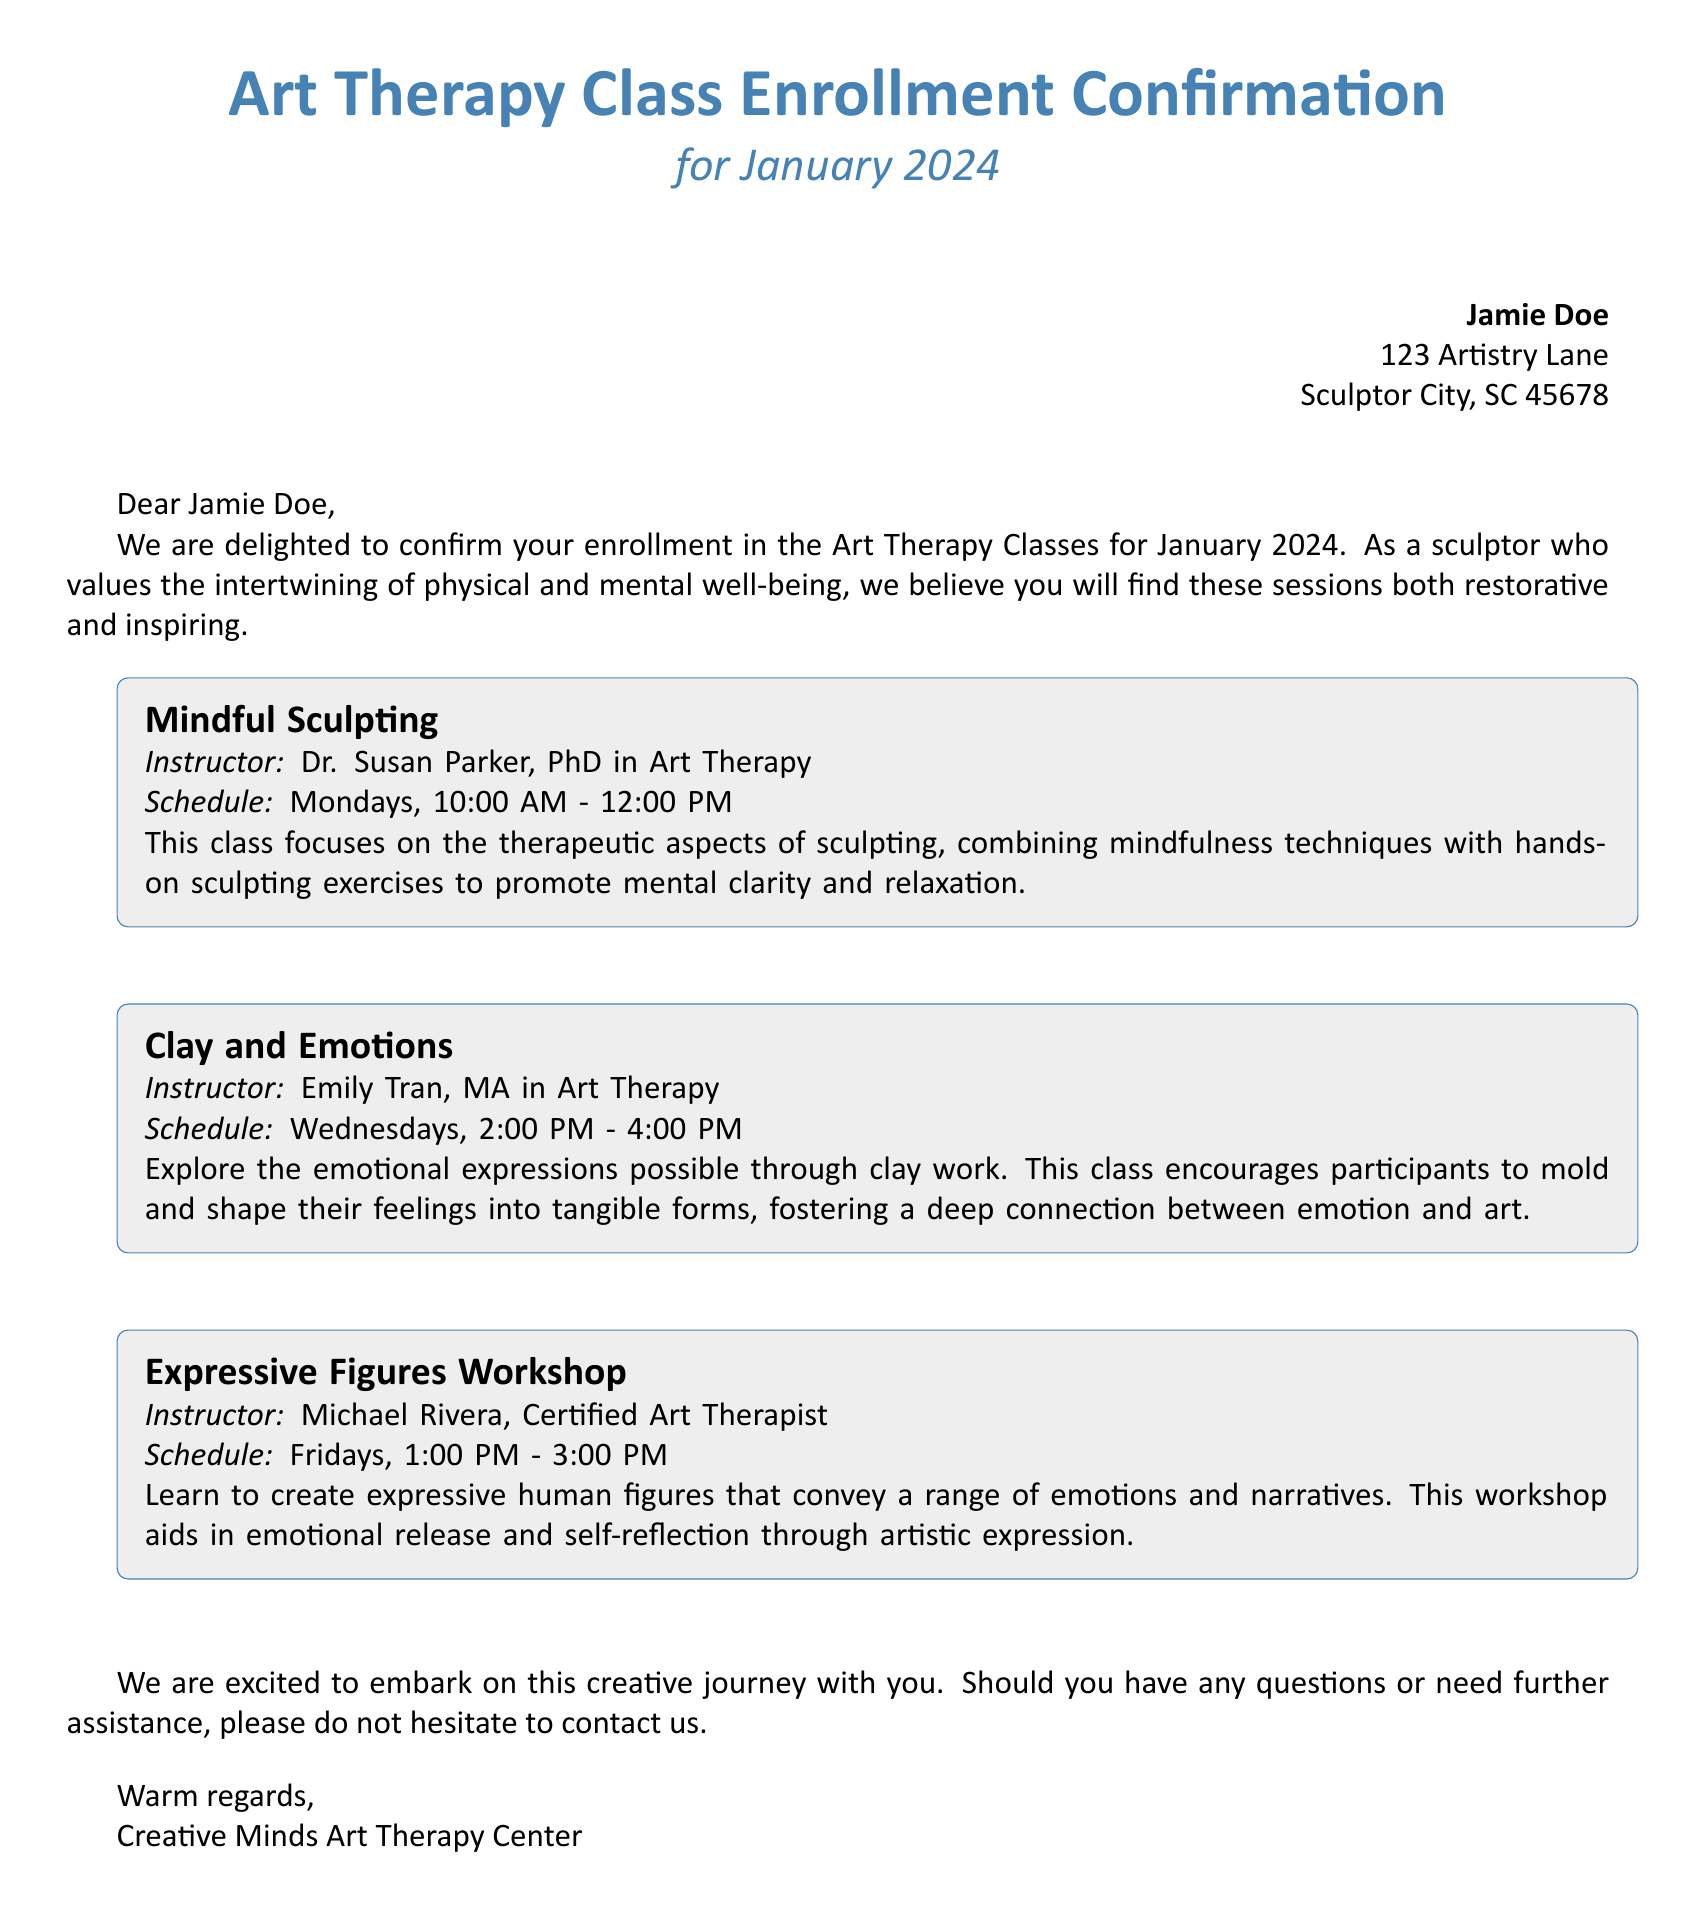What is the name of the instructor for the Mindful Sculpting class? The instructor for the Mindful Sculpting class is Dr. Susan Parker.
Answer: Dr. Susan Parker What is the schedule for the Clay and Emotions class? The schedule for the Clay and Emotions class is Wednesdays, 2:00 PM - 4:00 PM.
Answer: Wednesdays, 2:00 PM - 4:00 PM How many classes are listed in the document? There are three classes listed in the document.
Answer: Three What is the main focus of the Expressive Figures Workshop? The main focus of the Expressive Figures Workshop is to create expressive human figures that convey emotions and narratives.
Answer: Expressive human figures What day of the week does the Mindful Sculpting class occur? The Mindful Sculpting class occurs on Mondays.
Answer: Mondays What type of degree does Emily Tran hold? Emily Tran holds a Master's degree in Art Therapy.
Answer: MA in Art Therapy Who is the recipient of the enrollment confirmation? The recipient of the enrollment confirmation is Jamie Doe.
Answer: Jamie Doe What is one therapeutic technique mentioned for the Mindful Sculpting class? One therapeutic technique mentioned is mindfulness.
Answer: Mindfulness What is the overall tone of the enrollment confirmation letter? The overall tone of the enrollment confirmation letter is warm and welcoming.
Answer: Warm and welcoming What organization sent the confirmation letter? The organization that sent the confirmation letter is Creative Minds Art Therapy Center.
Answer: Creative Minds Art Therapy Center 